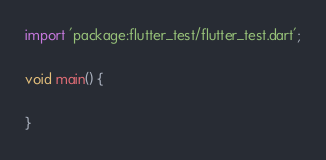Convert code to text. <code><loc_0><loc_0><loc_500><loc_500><_Dart_>import 'package:flutter_test/flutter_test.dart';

void main() {
  
}
</code> 